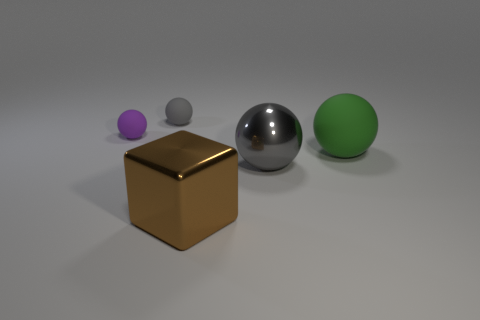There is a matte object that is on the right side of the brown thing; what number of large balls are in front of it?
Make the answer very short. 1. There is a object that is both in front of the green rubber object and right of the brown thing; what is its size?
Ensure brevity in your answer.  Large. How many metallic things are either cubes or tiny gray spheres?
Your response must be concise. 1. What is the material of the large green sphere?
Your response must be concise. Rubber. There is a gray thing in front of the small matte sphere that is to the left of the gray object left of the big brown block; what is it made of?
Your response must be concise. Metal. The brown object that is the same size as the green matte ball is what shape?
Offer a terse response. Cube. How many things are shiny objects or matte spheres that are behind the big rubber thing?
Offer a terse response. 4. Is the object right of the gray metal object made of the same material as the gray thing behind the large matte sphere?
Your answer should be compact. Yes. The small object that is the same color as the large shiny sphere is what shape?
Ensure brevity in your answer.  Sphere. How many gray things are either large rubber balls or spheres?
Provide a short and direct response. 2. 